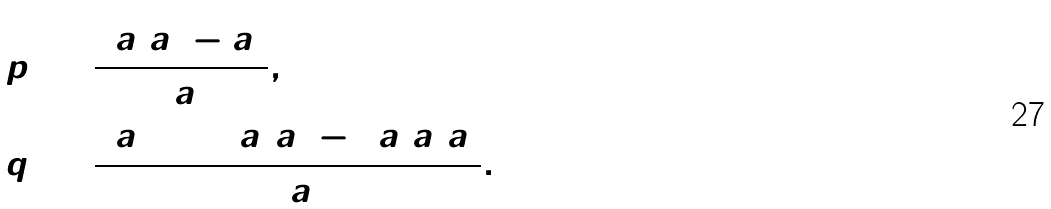Convert formula to latex. <formula><loc_0><loc_0><loc_500><loc_500>p & \ = \frac { 3 a _ { 0 } a _ { 2 } - a _ { 1 } ^ { 2 } } { 3 a _ { 0 } } , \\ q & \ = \frac { 2 a _ { 1 } ^ { 3 } + 2 7 a _ { 0 } ^ { 2 } a _ { 3 } - 9 a _ { 0 } a _ { 1 } a _ { 2 } } { 2 7 a _ { 0 } ^ { 2 } } .</formula> 